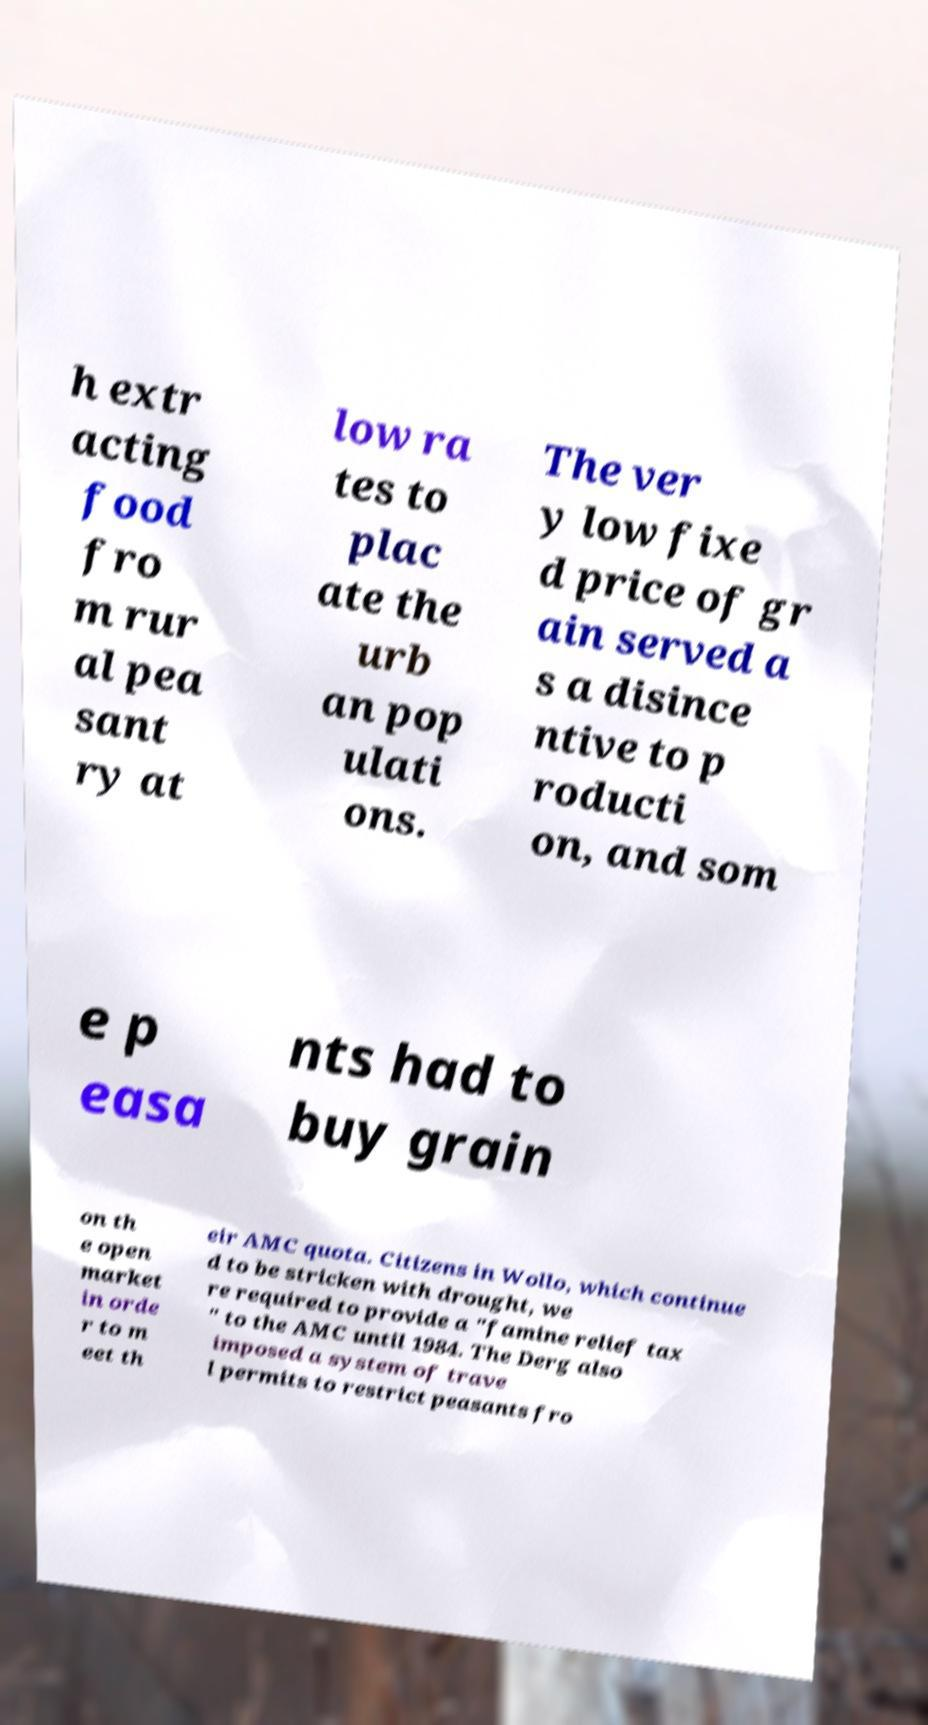Can you read and provide the text displayed in the image?This photo seems to have some interesting text. Can you extract and type it out for me? h extr acting food fro m rur al pea sant ry at low ra tes to plac ate the urb an pop ulati ons. The ver y low fixe d price of gr ain served a s a disince ntive to p roducti on, and som e p easa nts had to buy grain on th e open market in orde r to m eet th eir AMC quota. Citizens in Wollo, which continue d to be stricken with drought, we re required to provide a "famine relief tax " to the AMC until 1984. The Derg also imposed a system of trave l permits to restrict peasants fro 